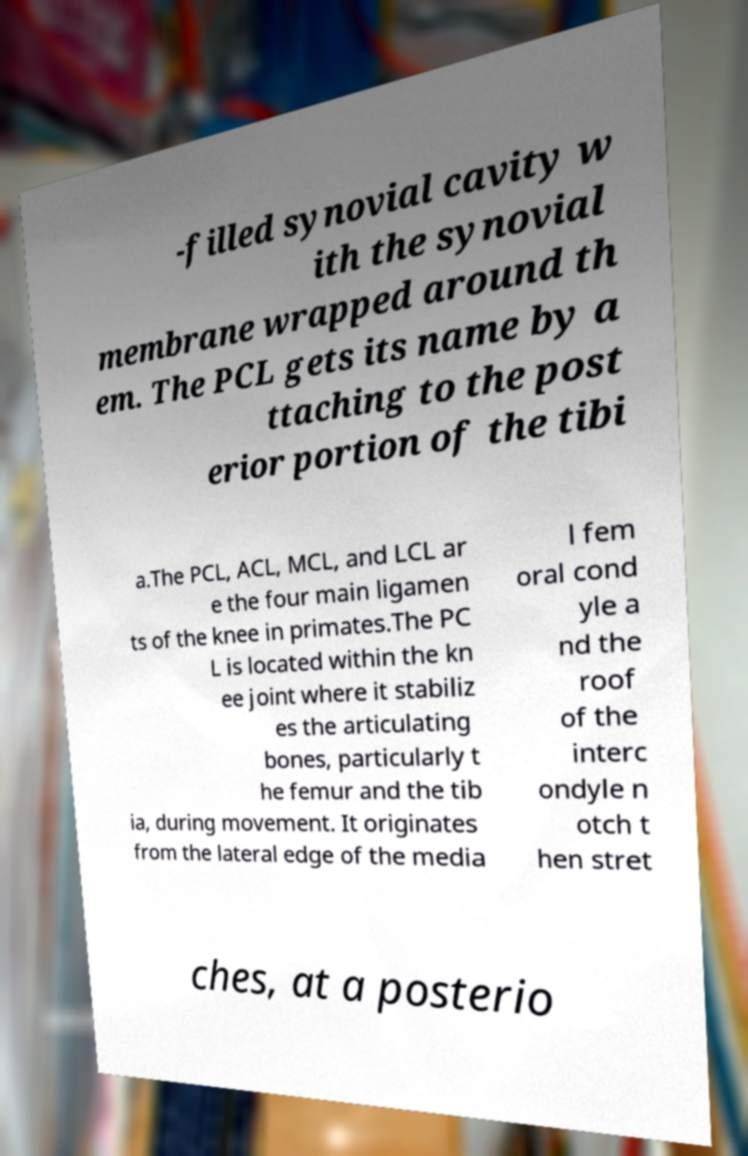Could you extract and type out the text from this image? -filled synovial cavity w ith the synovial membrane wrapped around th em. The PCL gets its name by a ttaching to the post erior portion of the tibi a.The PCL, ACL, MCL, and LCL ar e the four main ligamen ts of the knee in primates.The PC L is located within the kn ee joint where it stabiliz es the articulating bones, particularly t he femur and the tib ia, during movement. It originates from the lateral edge of the media l fem oral cond yle a nd the roof of the interc ondyle n otch t hen stret ches, at a posterio 